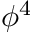<formula> <loc_0><loc_0><loc_500><loc_500>\phi ^ { 4 }</formula> 